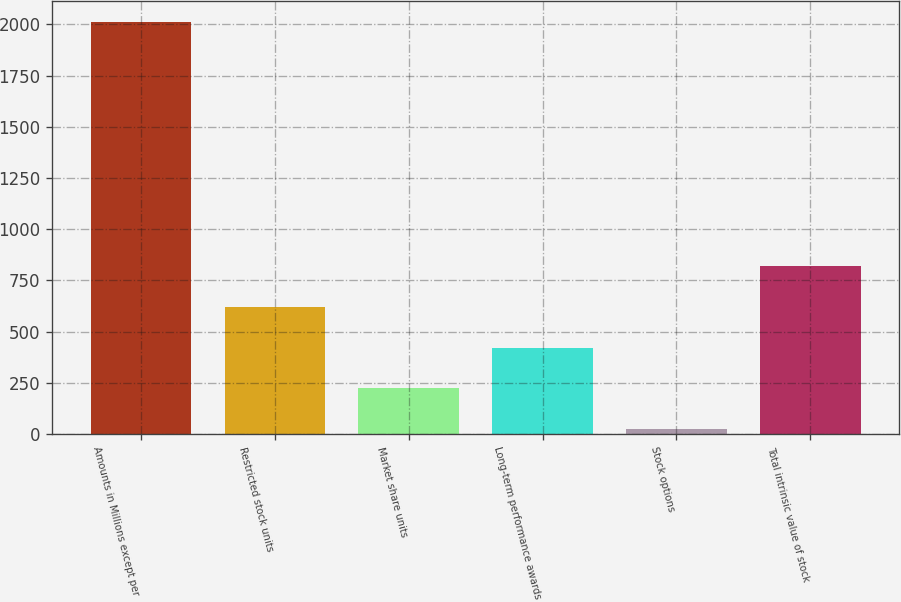Convert chart. <chart><loc_0><loc_0><loc_500><loc_500><bar_chart><fcel>Amounts in Millions except per<fcel>Restricted stock units<fcel>Market share units<fcel>Long-term performance awards<fcel>Stock options<fcel>Total intrinsic value of stock<nl><fcel>2012<fcel>619.7<fcel>221.9<fcel>420.8<fcel>23<fcel>818.6<nl></chart> 